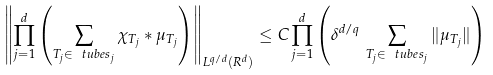Convert formula to latex. <formula><loc_0><loc_0><loc_500><loc_500>\left \| \prod _ { j = 1 } ^ { d } \left ( \sum _ { T _ { j } \in \ t u b e s _ { j } } \chi _ { T _ { j } } * \mu _ { T _ { j } } \right ) \right \| _ { L ^ { q / d } ( { R } ^ { d } ) } \leq C \prod _ { j = 1 } ^ { d } \left ( \delta ^ { d / q } \, \sum _ { T _ { j } \in \ t u b e s _ { j } } \| \mu _ { T _ { j } } \| \right )</formula> 